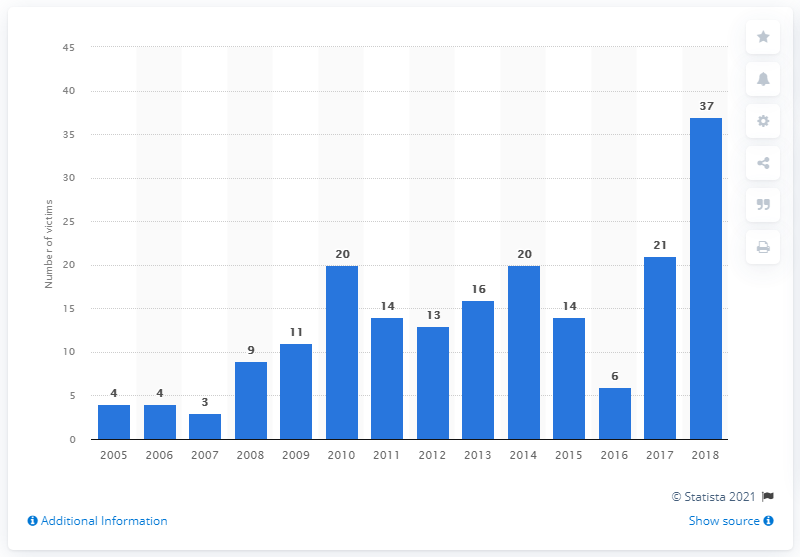Point out several critical features in this image. Last year, 21 Mexican municipal leaders were killed. In 2018, a total of 37 mayors, mayoral candidates, and former mayors were murdered in Mexico. 